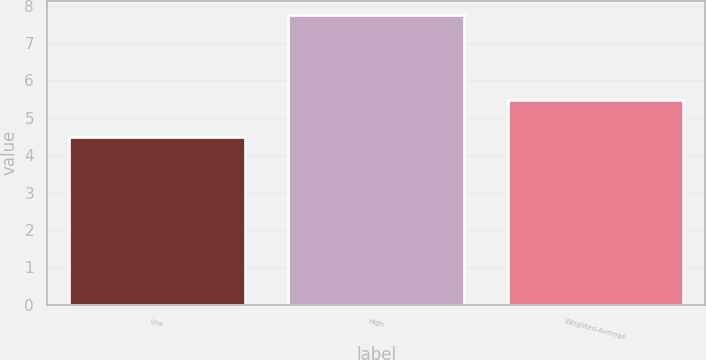Convert chart to OTSL. <chart><loc_0><loc_0><loc_500><loc_500><bar_chart><fcel>Low<fcel>High<fcel>Weighted-Average<nl><fcel>4.5<fcel>7.75<fcel>5.47<nl></chart> 